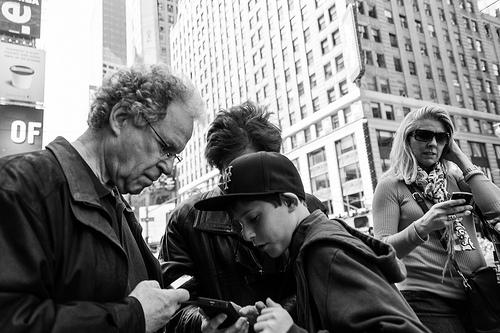Identify the prominent color in the image based on the descriptions of the objects present. Black is a prominent color as it is mentioned in the description of the hat, sunglasses, and jackets. How many people are looking at cell phones in the image? There are four people looking at cell phones. Provide the main sentiment in the image based on the activity of the people. The overall sentiment in the image reflects a sense of social disconnection as everyone is engrossed in their cell phones rather than communicating with each other. Analyze the interaction between the people in the image based on their actions. The people in the image are not interacting with each other, as they are all focused on their cell phones. Rate the image quality on a scale of 1 to 10 based on the clarity of the objects captured. The image quality can be rated as an 8, as most objects are clearly captured with detailed descriptions. Count and name the objects that are a part of the persons' outfits in the image. There are six outfit components visible: a black baseball hat, a pair of sunglasses, a man's jacket, a lady's scarf, a pair of spectacles, and a boy's jacket. List three objects that are part of the building described in the image. Closed windows, a hanging sign, and an advertisement. Provide a detailed description of the image scene including the people and their activities. The image features four people standing together, all engrossed in their cell phones. There's a man with curly hair, a woman in sunglasses, a boy in a baseball cap, and another young man in glasses. They are standing in front of a building with closed windows and a sign on the side. Describe the building in the image and the main features associated with it. The building appears to be a skyscraper in a big city with several closed windows, a sign hanging, and an advertisement on the side.  